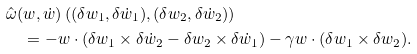<formula> <loc_0><loc_0><loc_500><loc_500>& \hat { \omega } ( w , \dot { w } ) \left ( ( \delta w _ { 1 } , \delta \dot { w } _ { 1 } ) , ( \delta w _ { 2 } , \delta \dot { w } _ { 2 } ) \right ) \\ & \quad = - w \cdot ( \delta w _ { 1 } \times \delta \dot { w } _ { 2 } - \delta w _ { 2 } \times \delta \dot { w } _ { 1 } ) - \gamma w \cdot ( \delta w _ { 1 } \times \delta w _ { 2 } ) .</formula> 